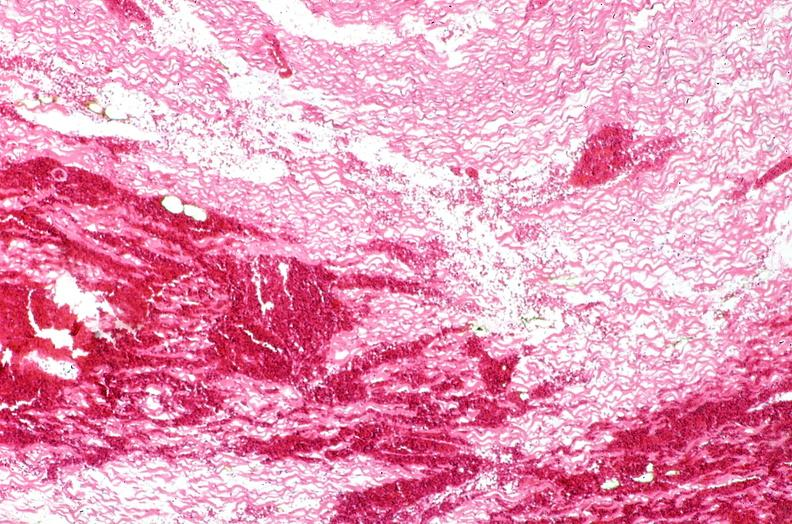does side show heart, myocardial infarction, wavey fiber change, necrtosis, hemorrhage, and dissection?
Answer the question using a single word or phrase. No 